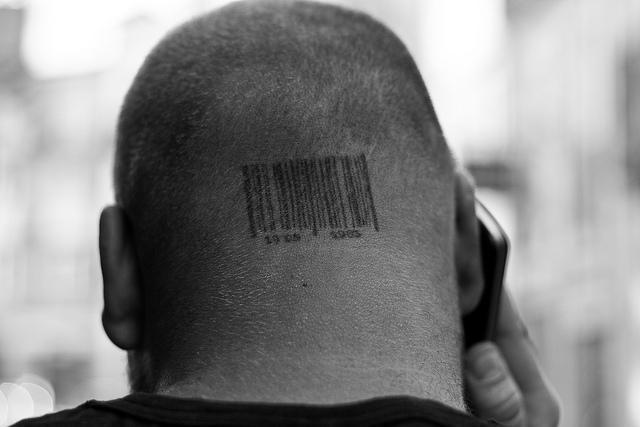How many forks are there?
Give a very brief answer. 0. 